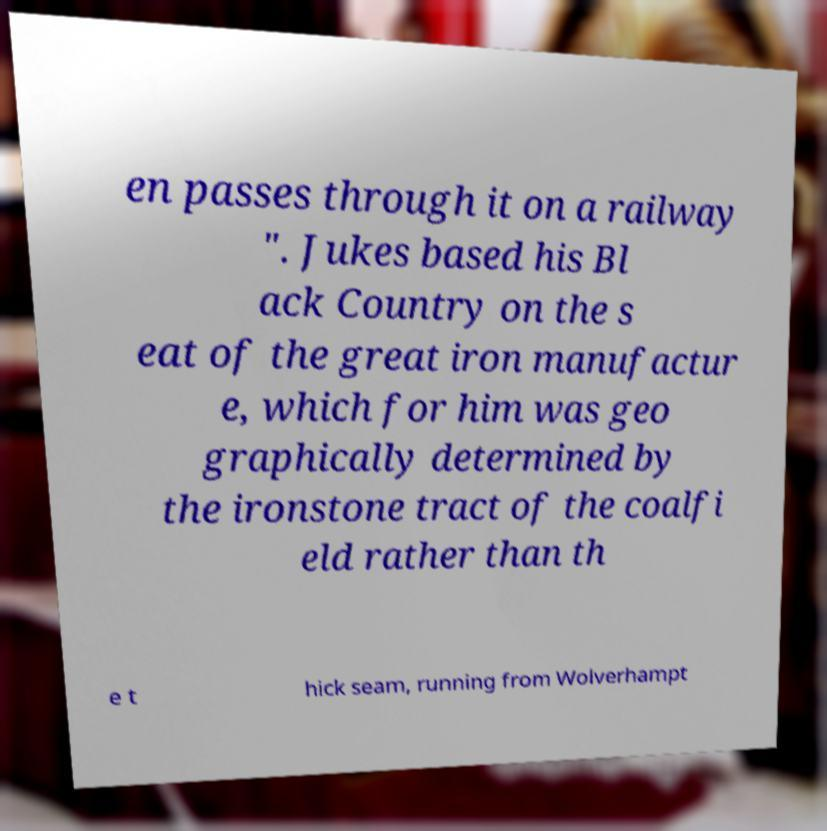There's text embedded in this image that I need extracted. Can you transcribe it verbatim? en passes through it on a railway ". Jukes based his Bl ack Country on the s eat of the great iron manufactur e, which for him was geo graphically determined by the ironstone tract of the coalfi eld rather than th e t hick seam, running from Wolverhampt 